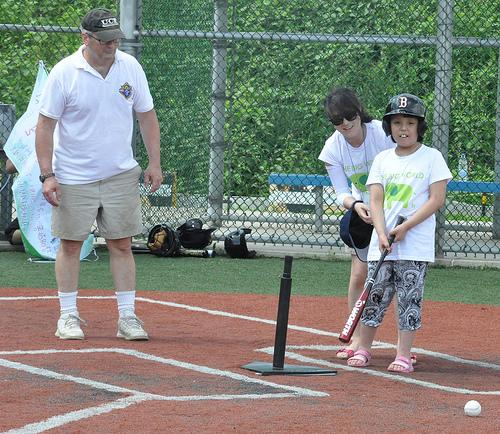Count and list the different clothing and accessories that the man is wearing. The man is wearing 5 clothing items and accessories: a black cap, white shirt, tan shorts, white socks, and grey shoes. Analyze the image and describe the background scenery, including any equipment or structures. The background features a metal gate behind the field, white lines on the turf, and equipment such as a group of black bags by a pole. What is the man wearing on his head and what color is it? The man is wearing a black cap on his head. List the people in the image and describe any noticeable emotions or expressions. There is a man wearing a cap and glasses, a woman wearing sunglasses and smiling, and a girl holding a baseball bat. The woman appears happy while the others' emotions are not clear. Which person in the image is holding a baseball bat, and what are the bat's colors? The girl is holding a baseball bat that is black and red. Assess the image for any evident interaction among the people or between people and objects. The girl is holding a baseball bat which suggests she might be preparing to play, and the woman standing behind her appears to be observing. Narrate the outfits and accessories of the girl and the woman standing behind her. The girl is wearing a black helmet, black and white pants, and pink shoes; she is also holding a red and black bat. The woman is wearing a white shirt and sunglasses, and she is smiling. Estimate the number of total objects and people combined in the image. There are approximately 29 objects and people combined in the image. Provide a brief description of the emotions or mood portrayed in the image. The image portrays a casual mood with the woman smiling and the girl holding a baseball bat, suggesting a recreational activity. How many objects are on the ground and what are they? There are three objects on the ground: a white baseball, some baseball hats, and a black stick. 